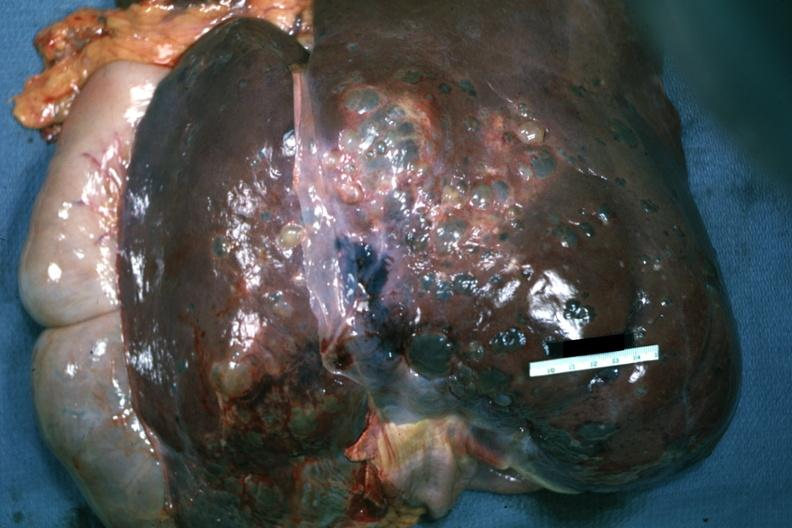s hepatobiliary present?
Answer the question using a single word or phrase. Yes 